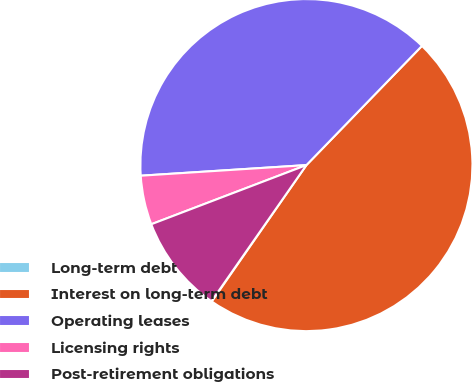<chart> <loc_0><loc_0><loc_500><loc_500><pie_chart><fcel>Long-term debt<fcel>Interest on long-term debt<fcel>Operating leases<fcel>Licensing rights<fcel>Post-retirement obligations<nl><fcel>0.04%<fcel>47.4%<fcel>38.27%<fcel>4.78%<fcel>9.51%<nl></chart> 